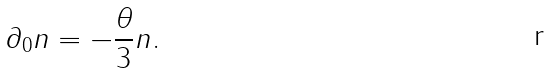<formula> <loc_0><loc_0><loc_500><loc_500>\partial _ { 0 } n = - \frac { \theta } { 3 } n .</formula> 